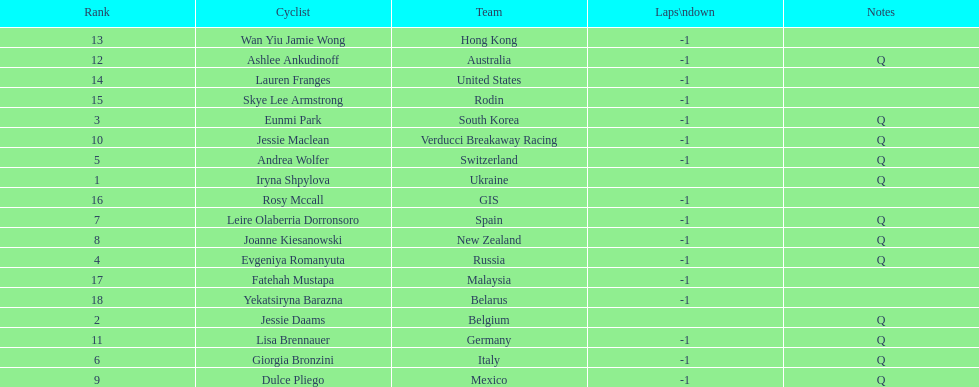What team is listed previous to belgium? Ukraine. 